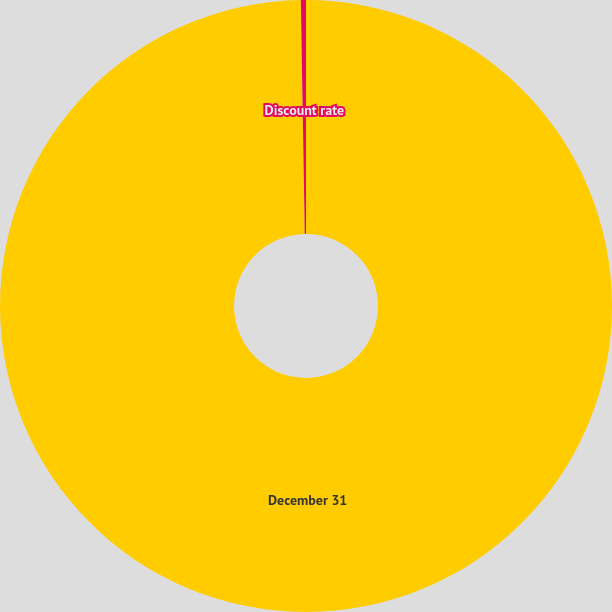<chart> <loc_0><loc_0><loc_500><loc_500><pie_chart><fcel>December 31<fcel>Discount rate<nl><fcel>99.73%<fcel>0.27%<nl></chart> 